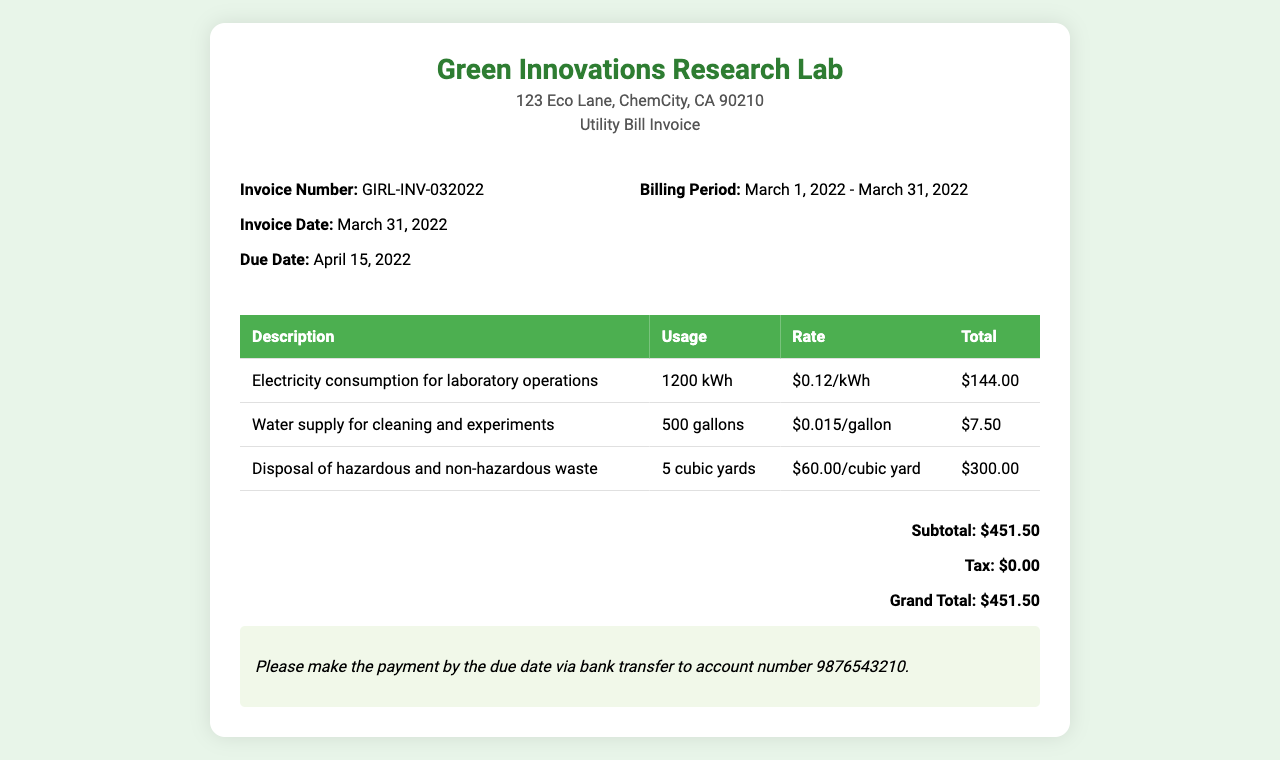what is the invoice number? The invoice number is listed under the invoice details section as "GIRL-INV-032022."
Answer: GIRL-INV-032022 what is the billing period? The billing period is specified in the invoice details section, which states "March 1, 2022 - March 31, 2022."
Answer: March 1, 2022 - March 31, 2022 how much is charged for electricity consumption? The total charge for electricity is calculated from the usage and rate, totaling $144.00.
Answer: $144.00 what is the total amount due? The grand total at the end of the invoice indicates the total amount due, which is $451.50.
Answer: $451.50 what is the rate per gallon of water? The rate for water supply is detailed in the table as "$0.015/gallon."
Answer: $0.015/gallon how many cubic yards of waste disposal were charged? The invoice states a charge for 5 cubic yards of waste disposal in the table.
Answer: 5 cubic yards when is the payment due? The due date for payment is listed as "April 15, 2022."
Answer: April 15, 2022 what type of invoice is this? The document is identified as a "Utility Bill Invoice" within the header.
Answer: Utility Bill Invoice how much tax is included in the invoice? The tax is explicitly stated as $0.00 in the invoice's total computation section.
Answer: $0.00 